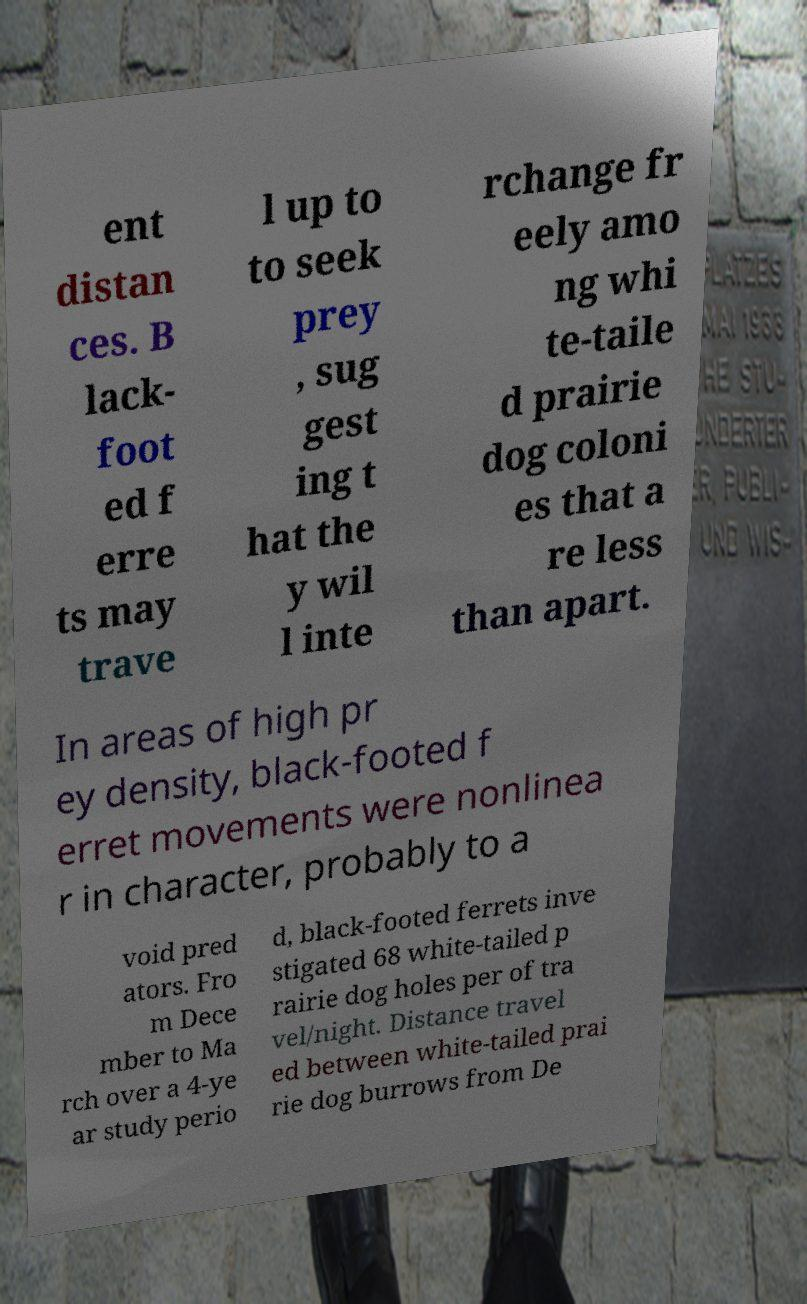Please read and relay the text visible in this image. What does it say? ent distan ces. B lack- foot ed f erre ts may trave l up to to seek prey , sug gest ing t hat the y wil l inte rchange fr eely amo ng whi te-taile d prairie dog coloni es that a re less than apart. In areas of high pr ey density, black-footed f erret movements were nonlinea r in character, probably to a void pred ators. Fro m Dece mber to Ma rch over a 4-ye ar study perio d, black-footed ferrets inve stigated 68 white-tailed p rairie dog holes per of tra vel/night. Distance travel ed between white-tailed prai rie dog burrows from De 